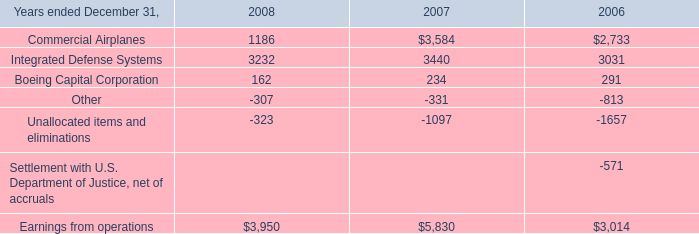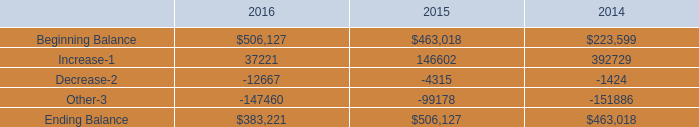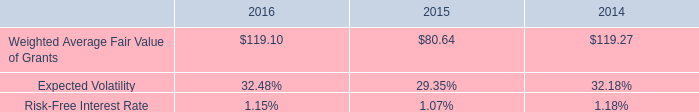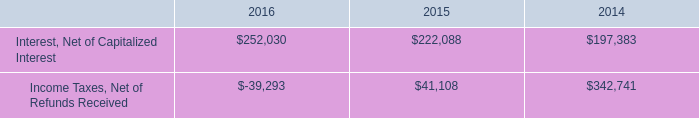What is the sum of Commercial Airplanes of 2007, and Beginning Balance of 2015 ? 
Computations: (3584.0 + 463018.0)
Answer: 466602.0. 